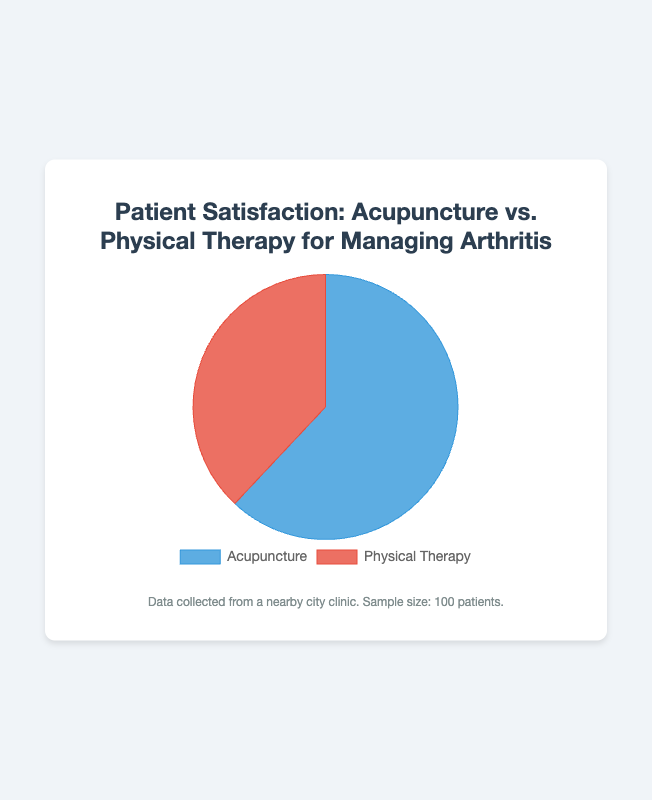What percentage of patients prefer physical therapy over acupuncture? From the pie chart, 38% of patients are satisfied with physical therapy for managing arthritis, while 62% prefer acupuncture. This means 38% of patients prefer physical therapy.
Answer: 38% Which treatment method has higher patient satisfaction? According to the pie chart, acupuncture has a satisfaction rate of 62%, while physical therapy has a satisfaction rate of 38%. Therefore, acupuncture has higher patient satisfaction.
Answer: Acupuncture How much higher is the patient satisfaction for acupuncture compared to physical therapy? From the pie chart, the satisfaction rate for acupuncture is 62% and for physical therapy is 38%. The difference is 62% - 38% = 24%.
Answer: 24% If there were 200 patients surveyed instead of 100, how many would be satisfied with acupuncture? The satisfaction rate for acupuncture is 62%. If 200 patients are surveyed, then 200 * 0.62 = 124 patients would be satisfied with acupuncture.
Answer: 124 What is the sum of the satisfaction percentages for both treatments? Summing up the satisfaction rates for acupuncture and physical therapy: 62% + 38% = 100%.
Answer: 100% What fraction of the patients prefers acupuncture? According to the pie chart, 62 out of 100 patients prefer acupuncture. This can be represented as a fraction: 62/100.
Answer: 62/100 What is the ratio of patients satisfied with acupuncture to those satisfied with physical therapy? From the chart, 62 patients are satisfied with acupuncture and 38 with physical therapy. The ratio is 62:38, which simplifies to 31:19.
Answer: 31:19 Which section of the pie chart is larger in area, and how is this visually represented? The section representing acupuncture is larger in the pie chart. Visually, this is represented by the larger portion of the pie, which has a greater angular span compared to the smaller portion representing physical therapy.
Answer: Acupuncture; larger portion 